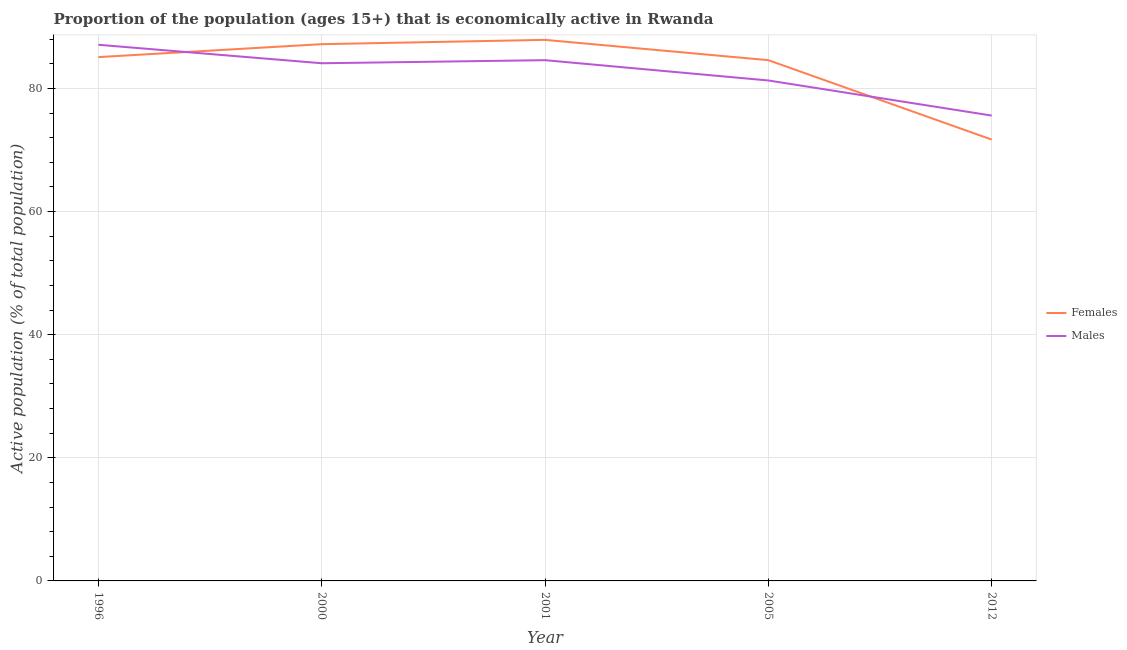Is the number of lines equal to the number of legend labels?
Provide a short and direct response. Yes. What is the percentage of economically active female population in 2001?
Make the answer very short. 87.9. Across all years, what is the maximum percentage of economically active male population?
Give a very brief answer. 87.1. Across all years, what is the minimum percentage of economically active male population?
Your response must be concise. 75.6. What is the total percentage of economically active female population in the graph?
Your answer should be compact. 416.5. What is the difference between the percentage of economically active female population in 2005 and that in 2012?
Your response must be concise. 12.9. What is the difference between the percentage of economically active female population in 1996 and the percentage of economically active male population in 2005?
Make the answer very short. 3.8. What is the average percentage of economically active male population per year?
Provide a short and direct response. 82.54. In the year 2005, what is the difference between the percentage of economically active female population and percentage of economically active male population?
Your answer should be very brief. 3.3. What is the ratio of the percentage of economically active female population in 2005 to that in 2012?
Your response must be concise. 1.18. Is the percentage of economically active male population in 1996 less than that in 2005?
Keep it short and to the point. No. Is the difference between the percentage of economically active male population in 1996 and 2001 greater than the difference between the percentage of economically active female population in 1996 and 2001?
Offer a terse response. Yes. What is the difference between the highest and the second highest percentage of economically active female population?
Provide a short and direct response. 0.7. What is the difference between the highest and the lowest percentage of economically active male population?
Provide a short and direct response. 11.5. In how many years, is the percentage of economically active female population greater than the average percentage of economically active female population taken over all years?
Provide a short and direct response. 4. Is the sum of the percentage of economically active male population in 2005 and 2012 greater than the maximum percentage of economically active female population across all years?
Give a very brief answer. Yes. Does the percentage of economically active female population monotonically increase over the years?
Your response must be concise. No. Is the percentage of economically active female population strictly less than the percentage of economically active male population over the years?
Your response must be concise. No. How many lines are there?
Your answer should be compact. 2. Are the values on the major ticks of Y-axis written in scientific E-notation?
Give a very brief answer. No. Where does the legend appear in the graph?
Ensure brevity in your answer.  Center right. How many legend labels are there?
Your response must be concise. 2. How are the legend labels stacked?
Give a very brief answer. Vertical. What is the title of the graph?
Provide a short and direct response. Proportion of the population (ages 15+) that is economically active in Rwanda. What is the label or title of the Y-axis?
Keep it short and to the point. Active population (% of total population). What is the Active population (% of total population) of Females in 1996?
Provide a short and direct response. 85.1. What is the Active population (% of total population) in Males in 1996?
Provide a short and direct response. 87.1. What is the Active population (% of total population) of Females in 2000?
Keep it short and to the point. 87.2. What is the Active population (% of total population) in Males in 2000?
Make the answer very short. 84.1. What is the Active population (% of total population) of Females in 2001?
Your answer should be compact. 87.9. What is the Active population (% of total population) in Males in 2001?
Provide a short and direct response. 84.6. What is the Active population (% of total population) of Females in 2005?
Offer a very short reply. 84.6. What is the Active population (% of total population) of Males in 2005?
Give a very brief answer. 81.3. What is the Active population (% of total population) in Females in 2012?
Offer a terse response. 71.7. What is the Active population (% of total population) in Males in 2012?
Keep it short and to the point. 75.6. Across all years, what is the maximum Active population (% of total population) in Females?
Your answer should be very brief. 87.9. Across all years, what is the maximum Active population (% of total population) of Males?
Provide a short and direct response. 87.1. Across all years, what is the minimum Active population (% of total population) in Females?
Provide a succinct answer. 71.7. Across all years, what is the minimum Active population (% of total population) in Males?
Your response must be concise. 75.6. What is the total Active population (% of total population) in Females in the graph?
Keep it short and to the point. 416.5. What is the total Active population (% of total population) in Males in the graph?
Give a very brief answer. 412.7. What is the difference between the Active population (% of total population) of Females in 1996 and that in 2000?
Offer a terse response. -2.1. What is the difference between the Active population (% of total population) in Males in 1996 and that in 2001?
Offer a terse response. 2.5. What is the difference between the Active population (% of total population) in Males in 1996 and that in 2005?
Your answer should be compact. 5.8. What is the difference between the Active population (% of total population) in Males in 1996 and that in 2012?
Provide a short and direct response. 11.5. What is the difference between the Active population (% of total population) in Males in 2000 and that in 2012?
Provide a succinct answer. 8.5. What is the difference between the Active population (% of total population) in Males in 2001 and that in 2005?
Ensure brevity in your answer.  3.3. What is the difference between the Active population (% of total population) of Females in 2001 and that in 2012?
Provide a succinct answer. 16.2. What is the difference between the Active population (% of total population) of Males in 2005 and that in 2012?
Give a very brief answer. 5.7. What is the difference between the Active population (% of total population) of Females in 1996 and the Active population (% of total population) of Males in 2000?
Make the answer very short. 1. What is the difference between the Active population (% of total population) of Females in 1996 and the Active population (% of total population) of Males in 2001?
Your answer should be compact. 0.5. What is the difference between the Active population (% of total population) of Females in 1996 and the Active population (% of total population) of Males in 2012?
Your response must be concise. 9.5. What is the difference between the Active population (% of total population) in Females in 2000 and the Active population (% of total population) in Males in 2001?
Your answer should be very brief. 2.6. What is the difference between the Active population (% of total population) in Females in 2000 and the Active population (% of total population) in Males in 2012?
Provide a short and direct response. 11.6. What is the difference between the Active population (% of total population) in Females in 2001 and the Active population (% of total population) in Males in 2012?
Keep it short and to the point. 12.3. What is the average Active population (% of total population) in Females per year?
Keep it short and to the point. 83.3. What is the average Active population (% of total population) in Males per year?
Keep it short and to the point. 82.54. In the year 2001, what is the difference between the Active population (% of total population) in Females and Active population (% of total population) in Males?
Your answer should be compact. 3.3. What is the ratio of the Active population (% of total population) in Females in 1996 to that in 2000?
Provide a succinct answer. 0.98. What is the ratio of the Active population (% of total population) of Males in 1996 to that in 2000?
Your response must be concise. 1.04. What is the ratio of the Active population (% of total population) in Females in 1996 to that in 2001?
Provide a succinct answer. 0.97. What is the ratio of the Active population (% of total population) of Males in 1996 to that in 2001?
Provide a succinct answer. 1.03. What is the ratio of the Active population (% of total population) in Females in 1996 to that in 2005?
Your response must be concise. 1.01. What is the ratio of the Active population (% of total population) in Males in 1996 to that in 2005?
Provide a short and direct response. 1.07. What is the ratio of the Active population (% of total population) in Females in 1996 to that in 2012?
Your answer should be compact. 1.19. What is the ratio of the Active population (% of total population) of Males in 1996 to that in 2012?
Your answer should be very brief. 1.15. What is the ratio of the Active population (% of total population) of Females in 2000 to that in 2005?
Your answer should be compact. 1.03. What is the ratio of the Active population (% of total population) of Males in 2000 to that in 2005?
Make the answer very short. 1.03. What is the ratio of the Active population (% of total population) in Females in 2000 to that in 2012?
Ensure brevity in your answer.  1.22. What is the ratio of the Active population (% of total population) in Males in 2000 to that in 2012?
Your answer should be compact. 1.11. What is the ratio of the Active population (% of total population) in Females in 2001 to that in 2005?
Keep it short and to the point. 1.04. What is the ratio of the Active population (% of total population) of Males in 2001 to that in 2005?
Make the answer very short. 1.04. What is the ratio of the Active population (% of total population) in Females in 2001 to that in 2012?
Your response must be concise. 1.23. What is the ratio of the Active population (% of total population) of Males in 2001 to that in 2012?
Your answer should be very brief. 1.12. What is the ratio of the Active population (% of total population) of Females in 2005 to that in 2012?
Ensure brevity in your answer.  1.18. What is the ratio of the Active population (% of total population) in Males in 2005 to that in 2012?
Offer a terse response. 1.08. What is the difference between the highest and the second highest Active population (% of total population) in Females?
Keep it short and to the point. 0.7. 